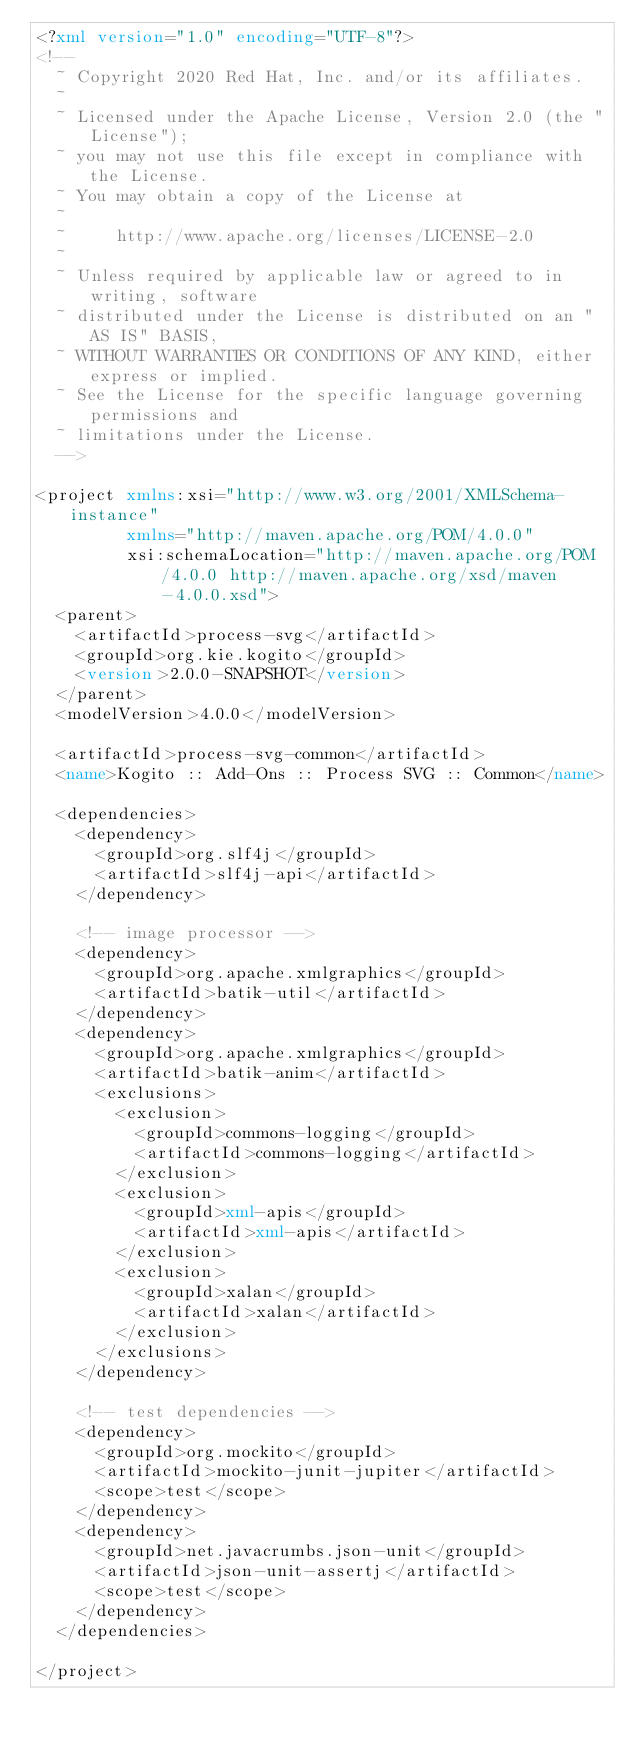<code> <loc_0><loc_0><loc_500><loc_500><_XML_><?xml version="1.0" encoding="UTF-8"?>
<!--
  ~ Copyright 2020 Red Hat, Inc. and/or its affiliates.
  ~
  ~ Licensed under the Apache License, Version 2.0 (the "License");
  ~ you may not use this file except in compliance with the License.
  ~ You may obtain a copy of the License at
  ~
  ~     http://www.apache.org/licenses/LICENSE-2.0
  ~
  ~ Unless required by applicable law or agreed to in writing, software
  ~ distributed under the License is distributed on an "AS IS" BASIS,
  ~ WITHOUT WARRANTIES OR CONDITIONS OF ANY KIND, either express or implied.
  ~ See the License for the specific language governing permissions and
  ~ limitations under the License.
  -->

<project xmlns:xsi="http://www.w3.org/2001/XMLSchema-instance"
         xmlns="http://maven.apache.org/POM/4.0.0"
         xsi:schemaLocation="http://maven.apache.org/POM/4.0.0 http://maven.apache.org/xsd/maven-4.0.0.xsd">
  <parent>
    <artifactId>process-svg</artifactId>
    <groupId>org.kie.kogito</groupId>
    <version>2.0.0-SNAPSHOT</version>
  </parent>
  <modelVersion>4.0.0</modelVersion>

  <artifactId>process-svg-common</artifactId>
  <name>Kogito :: Add-Ons :: Process SVG :: Common</name>

  <dependencies>
    <dependency>
      <groupId>org.slf4j</groupId>
      <artifactId>slf4j-api</artifactId>
    </dependency>

    <!-- image processor -->
    <dependency>
      <groupId>org.apache.xmlgraphics</groupId>
      <artifactId>batik-util</artifactId>
    </dependency>
    <dependency>
      <groupId>org.apache.xmlgraphics</groupId>
      <artifactId>batik-anim</artifactId>
      <exclusions>
        <exclusion>
          <groupId>commons-logging</groupId>
          <artifactId>commons-logging</artifactId>
        </exclusion>
        <exclusion>
          <groupId>xml-apis</groupId>
          <artifactId>xml-apis</artifactId>
        </exclusion>
        <exclusion>
          <groupId>xalan</groupId>
          <artifactId>xalan</artifactId>
        </exclusion>
      </exclusions>
    </dependency>

    <!-- test dependencies -->
    <dependency>
      <groupId>org.mockito</groupId>
      <artifactId>mockito-junit-jupiter</artifactId>
      <scope>test</scope>
    </dependency>
    <dependency>
      <groupId>net.javacrumbs.json-unit</groupId>
      <artifactId>json-unit-assertj</artifactId>
      <scope>test</scope>
    </dependency>
  </dependencies>

</project></code> 